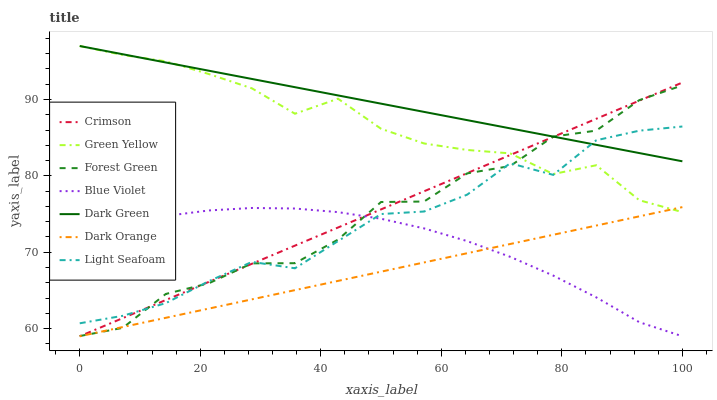Does Dark Orange have the minimum area under the curve?
Answer yes or no. Yes. Does Dark Green have the maximum area under the curve?
Answer yes or no. Yes. Does Light Seafoam have the minimum area under the curve?
Answer yes or no. No. Does Light Seafoam have the maximum area under the curve?
Answer yes or no. No. Is Dark Green the smoothest?
Answer yes or no. Yes. Is Forest Green the roughest?
Answer yes or no. Yes. Is Light Seafoam the smoothest?
Answer yes or no. No. Is Light Seafoam the roughest?
Answer yes or no. No. Does Dark Orange have the lowest value?
Answer yes or no. Yes. Does Light Seafoam have the lowest value?
Answer yes or no. No. Does Dark Green have the highest value?
Answer yes or no. Yes. Does Light Seafoam have the highest value?
Answer yes or no. No. Is Blue Violet less than Dark Green?
Answer yes or no. Yes. Is Green Yellow greater than Blue Violet?
Answer yes or no. Yes. Does Light Seafoam intersect Green Yellow?
Answer yes or no. Yes. Is Light Seafoam less than Green Yellow?
Answer yes or no. No. Is Light Seafoam greater than Green Yellow?
Answer yes or no. No. Does Blue Violet intersect Dark Green?
Answer yes or no. No. 